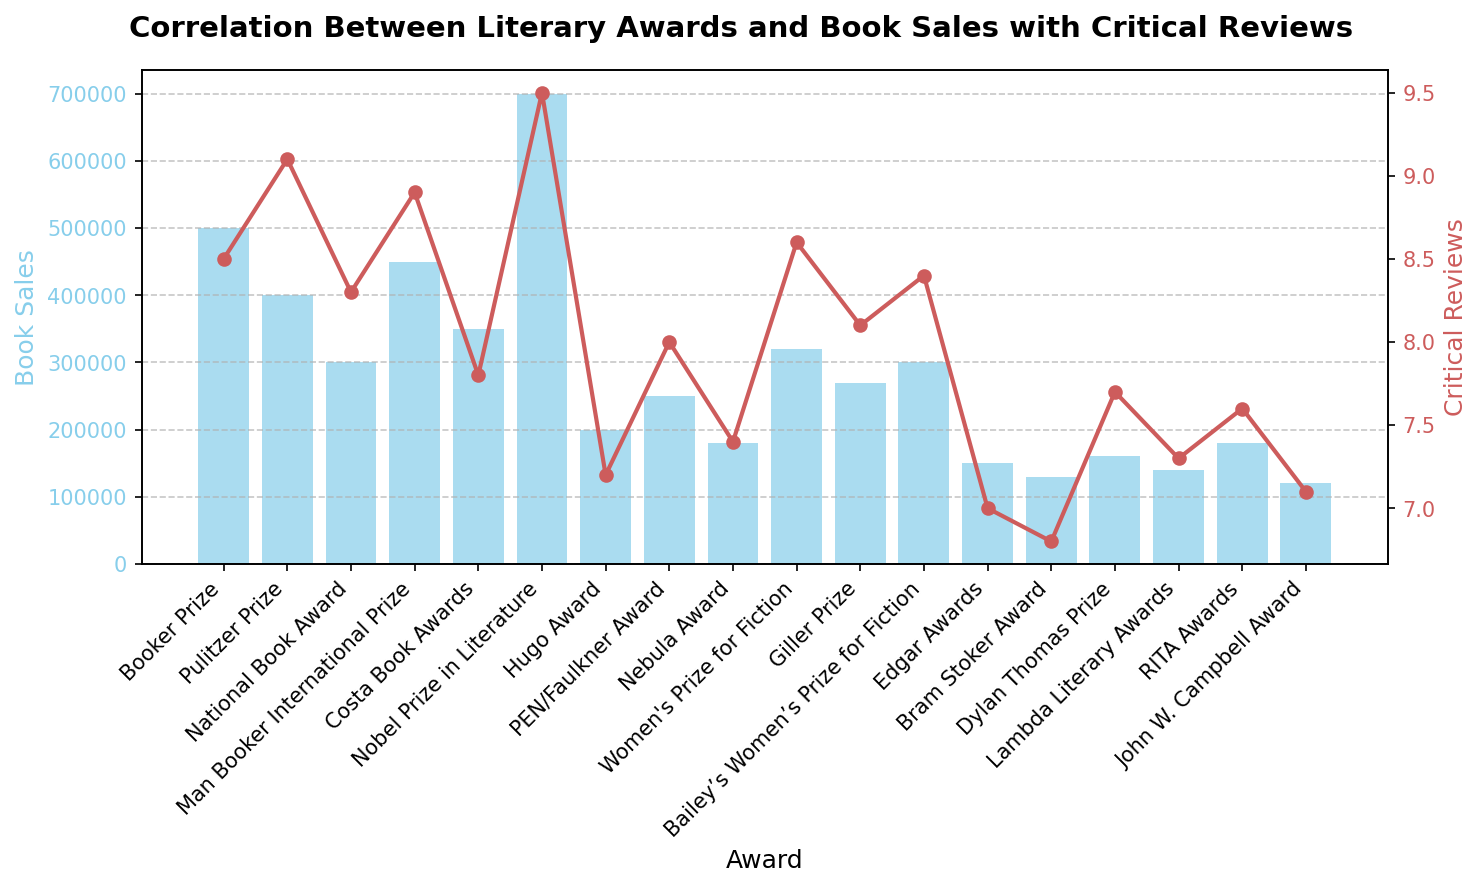How does the Nobel Prize in Literature compare to the Hugo Award in terms of book sales? To find the answer, refer to the heights of the bars for both the Nobel Prize in Literature and the Hugo Award. The Nobel Prize in Literature has a much higher bar, indicating higher book sales than the Hugo Award.
Answer: The Nobel Prize in Literature has higher book sales Which award has the highest critical reviews? Look at the highest point on the red line plot, which represents critical reviews. The Nobel Prize in Literature has the highest point on the plot.
Answer: Nobel Prize in Literature What is the difference in book sales between the Costa Book Awards and the Lambda Literary Awards? First, identify the book sales for both awards from the heights of their respective bars. The Costa Book Awards have 350,000 book sales, and the Lambda Literary Awards have 140,000 book sales. Subtract 140,000 from 350,000.
Answer: 210,000 Which awards have a critical review score higher than 9.0? Refer to the red line plot and identify the points that are above the 9.0 mark. The Nobel Prize in Literature and the Pulitzer Prize both have critical review scores higher than 9.0.
Answer: Nobel Prize in Literature, Pulitzer Prize How do the Booker Prize and Women's Prize for Fiction compare in terms of critical reviews and book sales? For the Booker Prize, book sales are 500,000 and critical reviews are 8.5. For the Women's Prize for Fiction, book sales are 320,000 and critical reviews are 8.6. Comparison shows that the Booker Prize has higher book sales, but the Women's Prize for Fiction has slightly higher critical reviews.
Answer: Booker Prize has higher book sales; Women's Prize for Fiction has slightly higher critical reviews What is the average book sales for the awards with the three highest critical reviews? The top three in critical reviews are the Nobel Prize in Literature (9.5), Pulitzer Prize (9.1), and Man Booker International Prize (8.9). Their book sales are 700,000, 400,000, and 450,000 respectively. Adding these gives (700,000 + 400,000 + 450,000) = 1,550,000, and dividing by 3 gives 1,550,000 / 3.
Answer: 516,667 By how much do the Dylan Thomas Prize book sales exceed those of the John W. Campbell Award? The book sales for the Dylan Thomas Prize are 160,000 and for the John W. Campbell Award are 120,000. Subtract 120,000 from 160,000.
Answer: 40,000 Which award has the lowest book sales and what is its critical review score? The lowest bar on the chart represents the award with the lowest book sales. This is the John W. Campbell Award, which has book sales of 120,000 and a critical review score of 7.1.
Answer: John W. Campbell Award, 7.1 What is the relationship between critical review scores and book sales for the Women's Prize for Fiction compared to the Bailey’s Women’s Prize for Fiction? The Women's Prize for Fiction has book sales of 320,000 and a critical review score of 8.6. The Bailey's Women’s Prize for Fiction has book sales of 300,000 and a critical review score of 8.4. The Women's Prize for Fiction has slightly higher values in both metrics.
Answer: Women's Prize for Fiction has higher values for both metrics Which two awards have the closest critical review scores, and what are those scores? Identify the points in the red line plot that are closest to each other in height. The Lambda Literary Awards have a score of 7.3, and the RITA Awards have a score of 7.6, making them close.
Answer: Lambda Literary Awards (7.3), RITA Awards (7.6) 